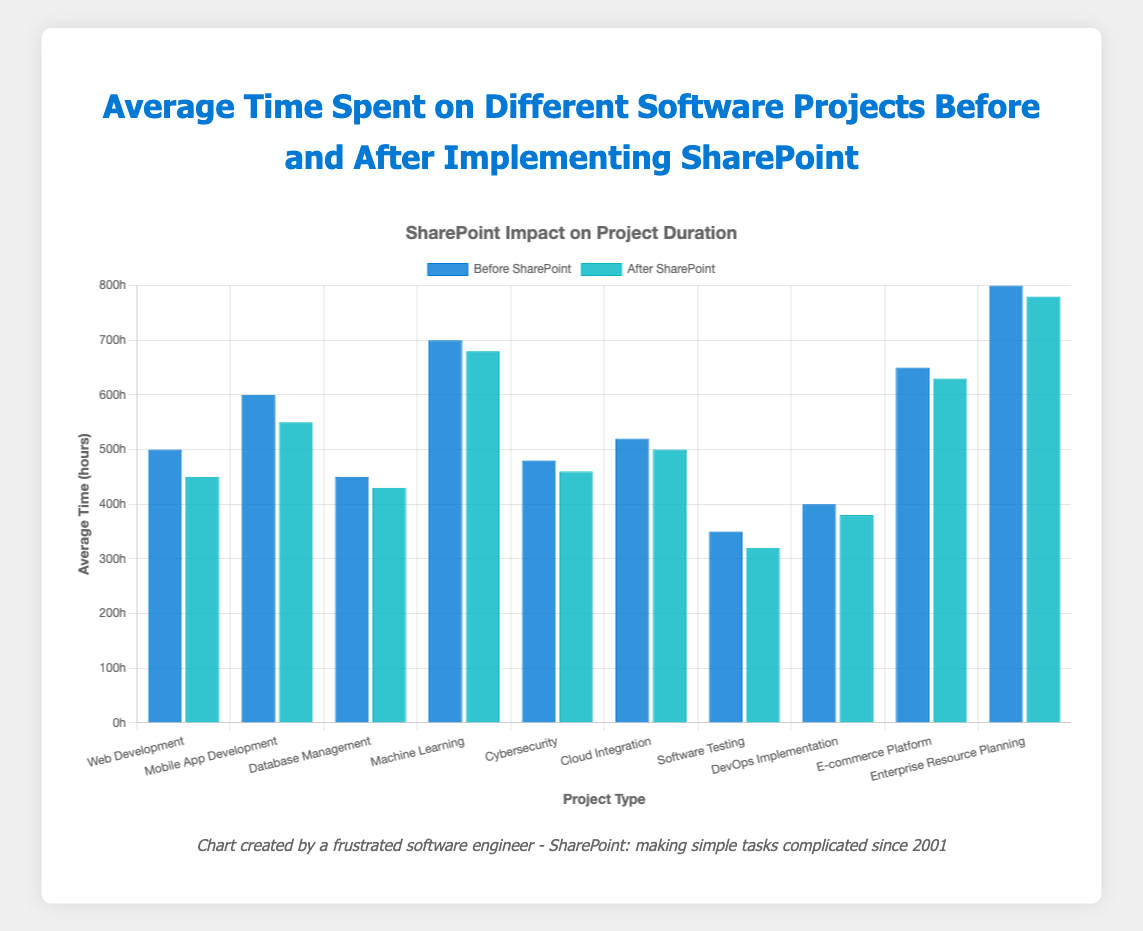What's the project type with the greatest reduction in average time after implementing SharePoint? To find the project type with the greatest reduction in time, subtract the "Average Time After SharePoint (hours)" from the "Average Time Before SharePoint (hours)" for each project. The one with the highest difference is the answer.
Answer: Software Testing How many hours were saved on Machine Learning projects after SharePoint was implemented? Subtract the "Average Time After SharePoint (hours)" from the "Average Time Before SharePoint (hours)" for Machine Learning projects: 700 - 680.
Answer: 20 Which project type saw the least improvement in time efficiency after implementing SharePoint? Compare the differences between the "Average Time Before SharePoint (hours)" and "Average Time After SharePoint (hours)" for all project types. The smallest positive difference indicates the least improvement.
Answer: Machine Learning What's the average reduction in time across all the project types after implementing SharePoint? Calculate the reduction for each project type, sum these reductions, and then divide by the number of project types. The reductions are: (500-450) + (600-550) + (450-430) + (700-680) + (480-460) + (520-500) + (350-320) + (400-380) + (650-630) + (800-780) = 410. Divide this sum by 10 project types.
Answer: 41 hours Which project type had the highest average hours spent before implementing SharePoint? Identify the project type with the highest "Average Time Before SharePoint (hours)" in the dataset.
Answer: Enterprise Resource Planning What is the total time saved across all project types after implementing SharePoint? Add up the time saved for each project type: (500-450) + (600-550) + (450-430) + (700-680) + (480-460) + (520-500) + (350-320) + (400-380) + (650-630) + (800-780) = 410 hours total saved.
Answer: 410 hours Compare the average time saved for Mobile App Development and Web Development projects. Which one is higher? Calculate the time saved for both: Mobile App Development (600-550 = 50) and Web Development (500-450 = 50). Both show the same amount of time saved.
Answer: Equal What color represents the average time before implementing SharePoint in the bar chart? Identify the color used for bars representing "Average Time Before SharePoint (hours)". In this case, the bars are blue.
Answer: Blue Which project types had an average time after implementing SharePoint less than 350 hours? Identify project types where "Average Time After SharePoint (hours)" is less than 350: Only "Software Testing" meets this criterion with 320 hours.
Answer: Software Testing What is the sum of the average times after implementing SharePoint for all project types? Add the "Average Time After SharePoint (hours)" for all projects: 450 + 550 + 430 + 680 + 460 + 500 + 320 + 380 + 630 + 780 = 5180 hours.
Answer: 5180 hours 